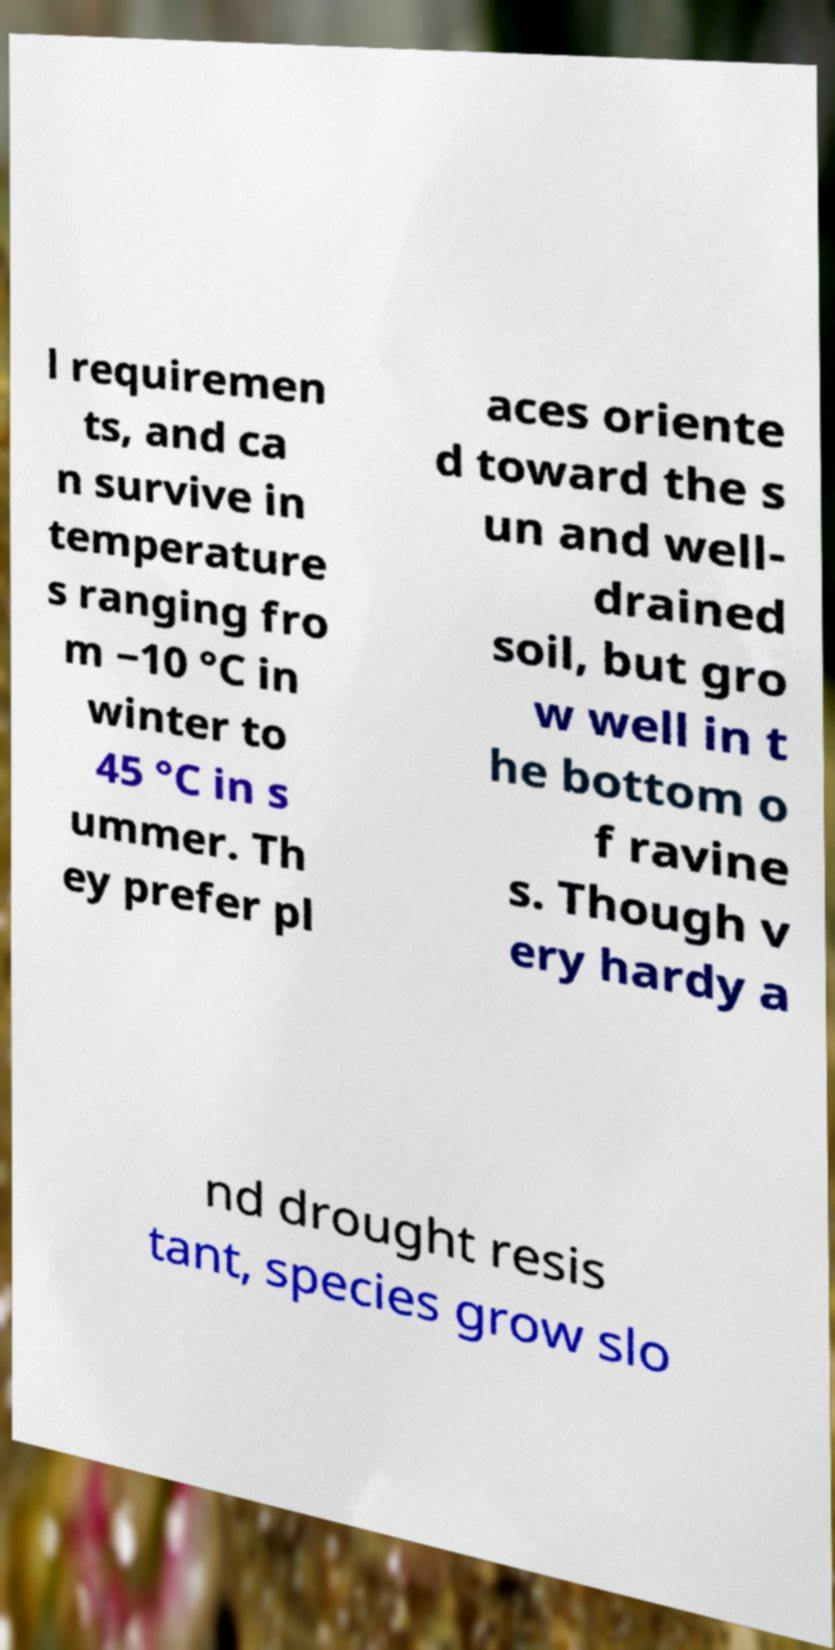There's text embedded in this image that I need extracted. Can you transcribe it verbatim? l requiremen ts, and ca n survive in temperature s ranging fro m −10 °C in winter to 45 °C in s ummer. Th ey prefer pl aces oriente d toward the s un and well- drained soil, but gro w well in t he bottom o f ravine s. Though v ery hardy a nd drought resis tant, species grow slo 